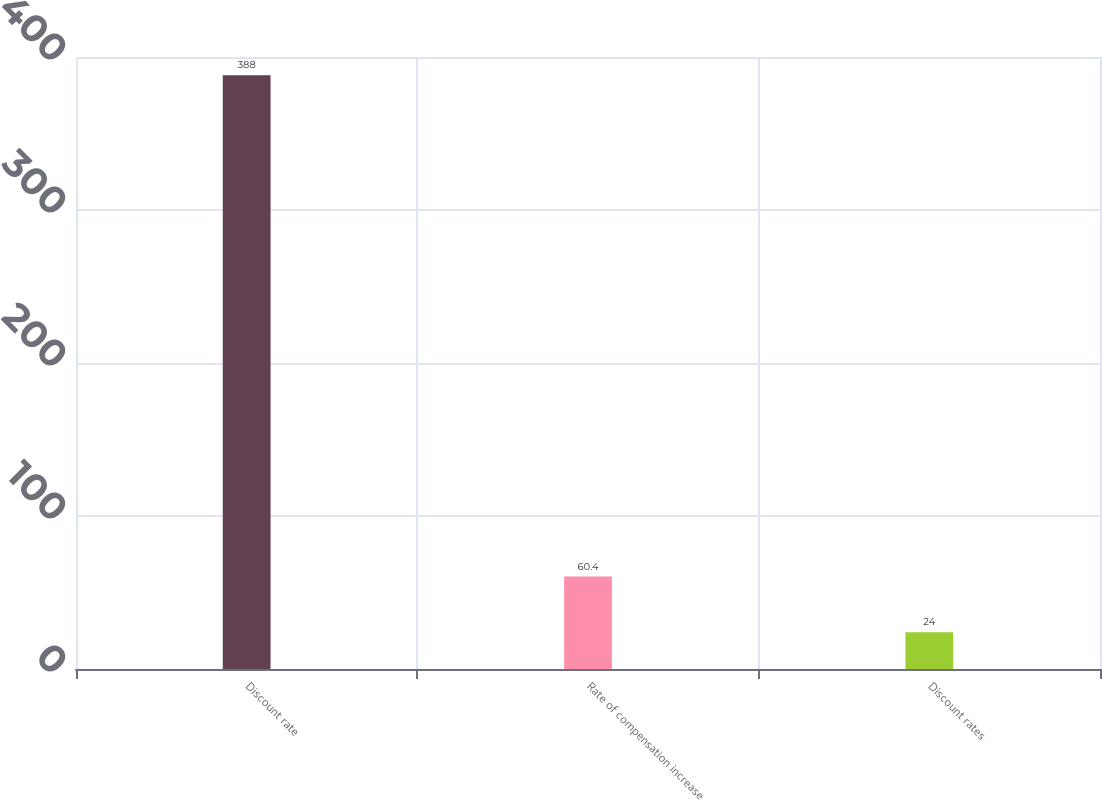Convert chart to OTSL. <chart><loc_0><loc_0><loc_500><loc_500><bar_chart><fcel>Discount rate<fcel>Rate of compensation increase<fcel>Discount rates<nl><fcel>388<fcel>60.4<fcel>24<nl></chart> 